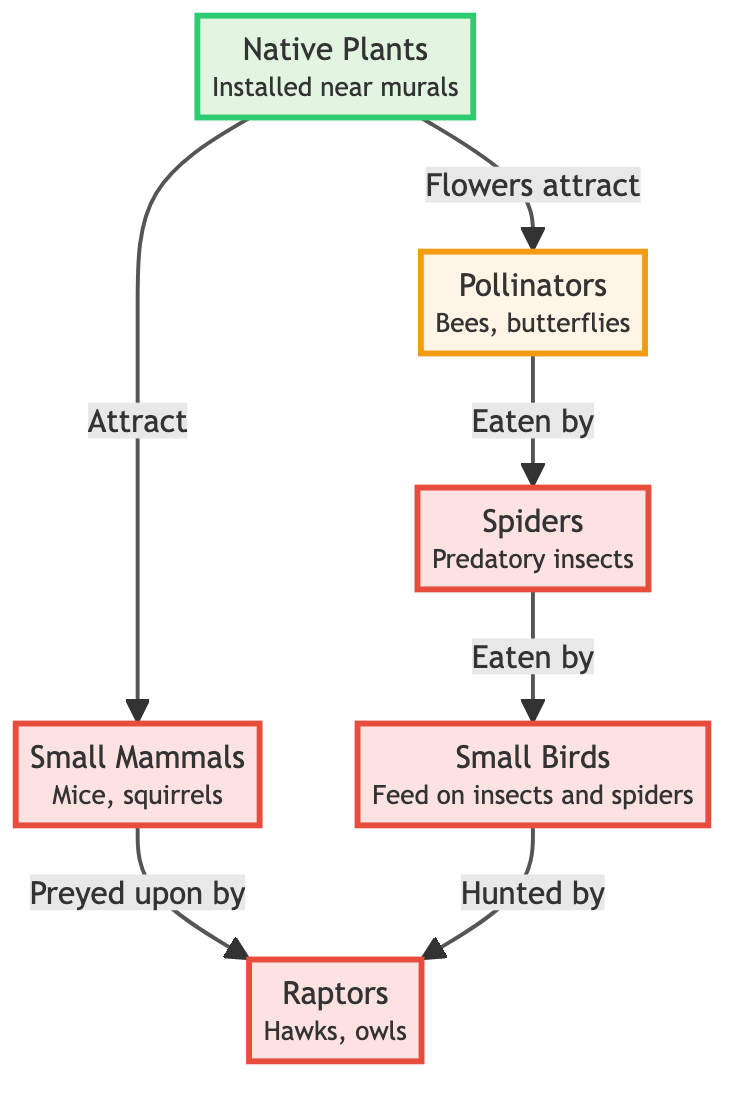What are the plants installed near murals? The diagram identifies "Native Plants" as the plants installed near murals by explicitly mentioning them in the node.
Answer: Native Plants How many types of predators are shown in the diagram? By examining the predator nodes in the diagram, we can see there are four types: spiders, birds, small mammals, and raptors.
Answer: 4 What do flowers attract? The diagram directly states that flowers attract insects, which is specified in the flow from the plant node to the insects node.
Answer: Insects Who eats the spiders? The diagram illustrates that spiders are eaten by birds, as shown by the directed edge leading from the spiders node to the birds node.
Answer: Birds What is the role of native plants in the food chain? Native plants provide food for insects and small mammals, as indicated by their connections to both the insects and small mammals nodes.
Answer: Attract insects and small mammals Which animals are preyed upon by raptors? The diagram indicates that raptors hunt both birds and small mammals, as both nodes are directly connected to the raptors node.
Answer: Birds and small mammals How many edges are connecting the insects and spiders? The diagram has one edge connecting the insects and spiders, which represents the predation relationship, thereby making it a single directed connection.
Answer: 1 What type of animals are classified as raptors? The diagram specifies raptors as "Hawks, owls," which are explicitly mentioned in the raptors node.
Answer: Hawks, owls What is the first link in this food chain? The first link in the food chain is the connection between native plants and insects; native plants attract insects, starting the flow of energy.
Answer: Native Plants to Insects 